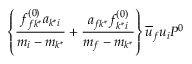Convert formula to latex. <formula><loc_0><loc_0><loc_500><loc_500>\left \{ \frac { f _ { f k ^ { * } } ^ { ( 0 ) } a _ { k ^ { * } i } } { m _ { i } - m _ { k ^ { * } } } + \frac { a _ { f k ^ { * } } f _ { k ^ { * } i } ^ { ( 0 ) } } { m _ { f } - m _ { k ^ { * } } } \right \} \overline { u } _ { f } u _ { i } P ^ { 0 }</formula> 